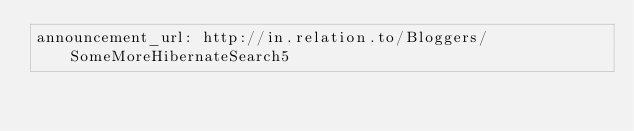Convert code to text. <code><loc_0><loc_0><loc_500><loc_500><_YAML_>announcement_url: http://in.relation.to/Bloggers/SomeMoreHibernateSearch5
</code> 